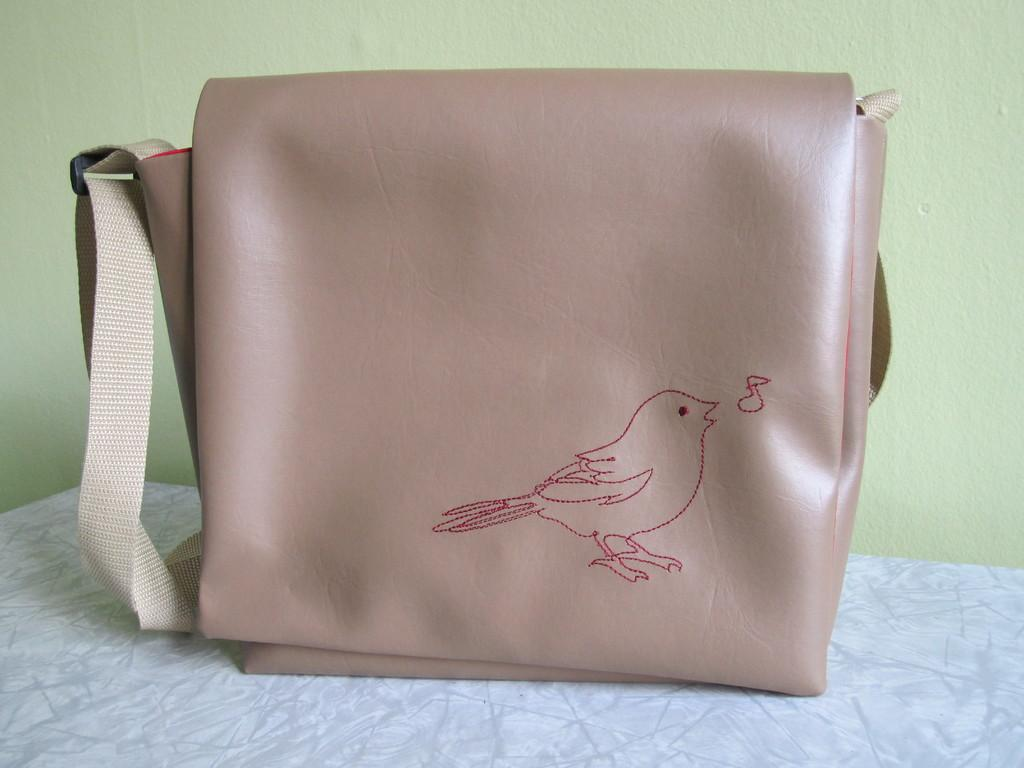What object is present in the image that can be used for carrying items? There is a bag in the image that can be used for carrying items. How is the bag secured in the image? The bag has a belt in the image. What symbol is present on the bag? The bag has a bird symbol on it. Where is the bag located in the image? The bag is placed on the floor in the image. What color is the wall visible in the background of the image? The wall in the background of the image is green. Can you see a key attached to the bird symbol on the bag in the image? There is no key attached to the bird symbol on the bag in the image. What type of truck is parked next to the bag in the image? There is no truck present in the image; it only features a bag with a bird symbol on it. 